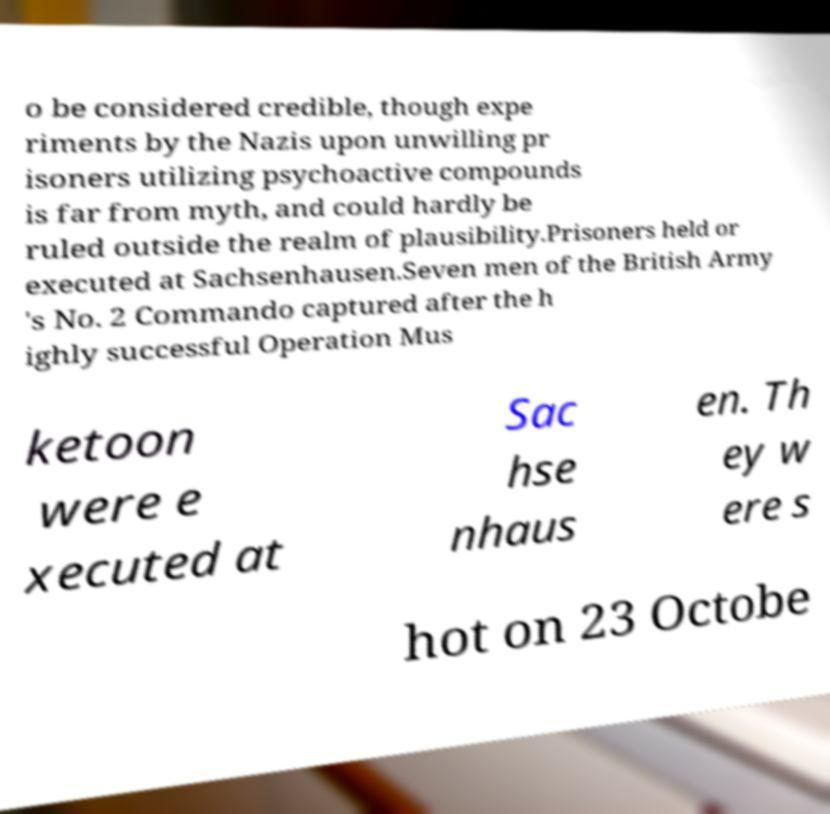Could you assist in decoding the text presented in this image and type it out clearly? o be considered credible, though expe riments by the Nazis upon unwilling pr isoners utilizing psychoactive compounds is far from myth, and could hardly be ruled outside the realm of plausibility.Prisoners held or executed at Sachsenhausen.Seven men of the British Army 's No. 2 Commando captured after the h ighly successful Operation Mus ketoon were e xecuted at Sac hse nhaus en. Th ey w ere s hot on 23 Octobe 